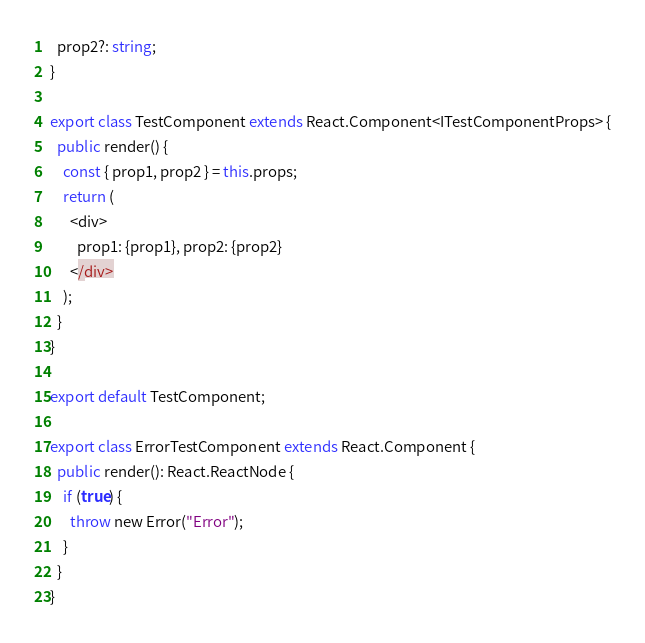<code> <loc_0><loc_0><loc_500><loc_500><_TypeScript_>  prop2?: string;
}

export class TestComponent extends React.Component<ITestComponentProps> {
  public render() {
    const { prop1, prop2 } = this.props;
    return (
      <div>
        prop1: {prop1}, prop2: {prop2}
      </div>
    );
  }
}

export default TestComponent;

export class ErrorTestComponent extends React.Component {
  public render(): React.ReactNode {
    if (true) {
      throw new Error("Error");
    }
  }
}</code> 